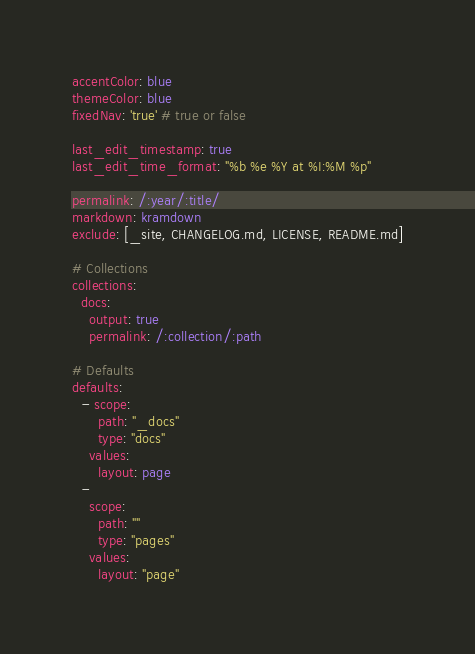Convert code to text. <code><loc_0><loc_0><loc_500><loc_500><_YAML_>accentColor: blue
themeColor: blue
fixedNav: 'true' # true or false

last_edit_timestamp: true
last_edit_time_format: "%b %e %Y at %I:%M %p"

permalink: /:year/:title/
markdown: kramdown
exclude: [_site, CHANGELOG.md, LICENSE, README.md]

# Collections
collections:
  docs:
    output: true
    permalink: /:collection/:path

# Defaults
defaults:
  - scope:
      path: "_docs"
      type: "docs"
    values:
      layout: page
  -
    scope:
      path: ""
      type: "pages"
    values:
      layout: "page"
</code> 